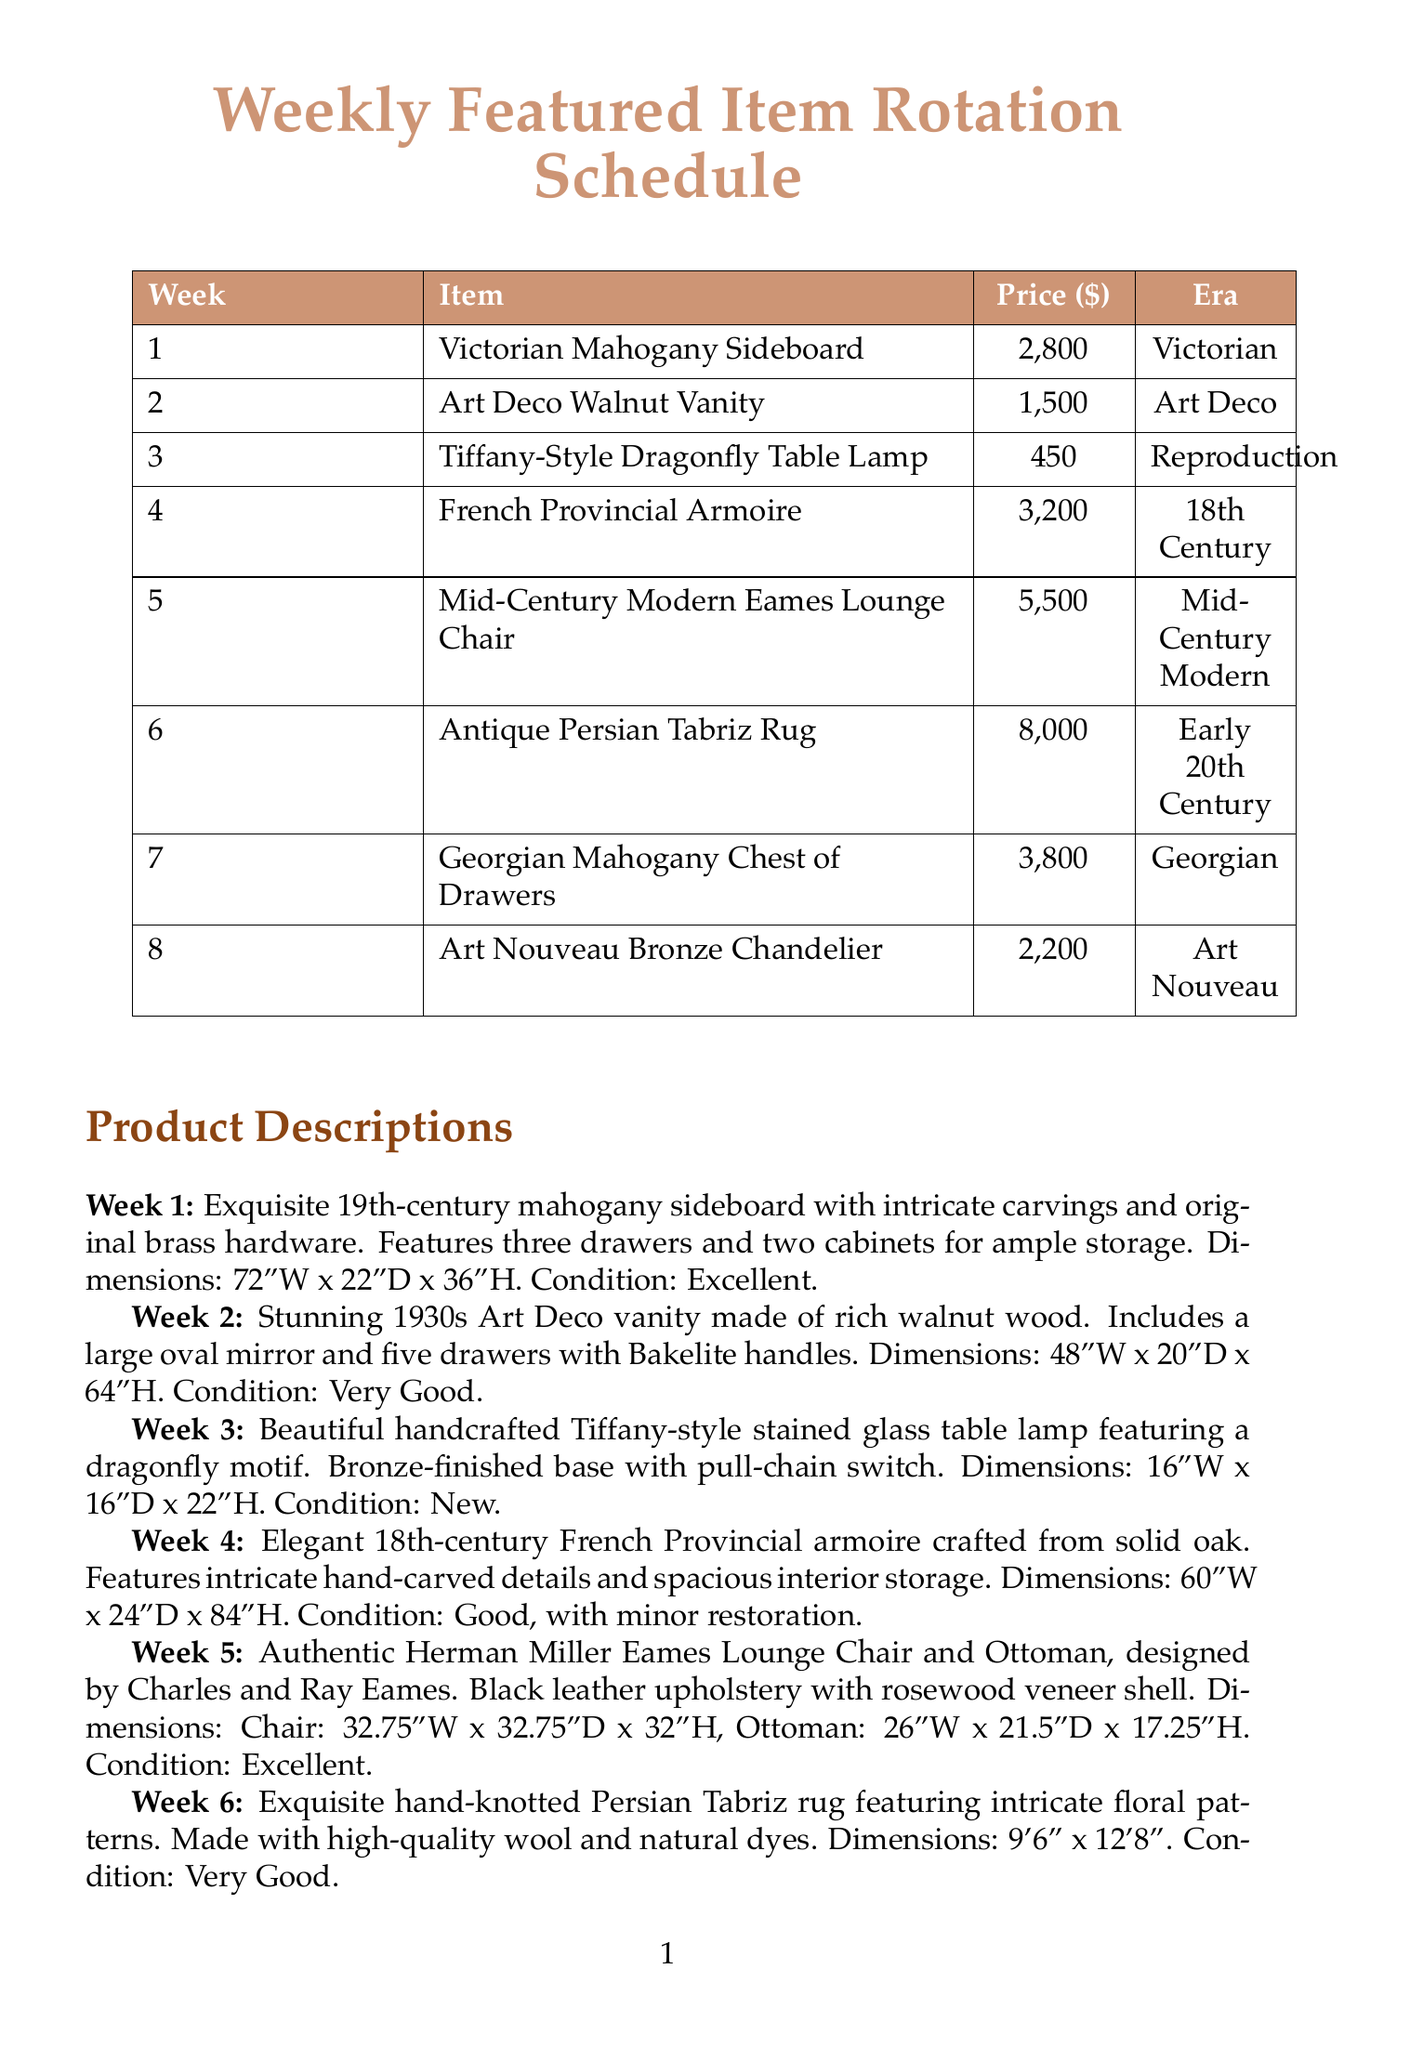What is the price of the Victorian Mahogany Sideboard? The price of the Victorian Mahogany Sideboard is listed in the schedule.
Answer: 2800 What item is featured in week 4? Week 4 features a specific item, which is documented in the schedule.
Answer: French Provincial Armoire What is the condition of the Antique Persian Tabriz Rug? The condition of the Antique Persian Tabriz Rug is provided in its description.
Answer: Very Good How many drawers does the Art Deco Walnut Vanity have? The number of drawers in the Art Deco Walnut Vanity is specified in its description.
Answer: Five Which era does the Mid-Century Modern Eames Lounge Chair belong to? The era associated with the Mid-Century Modern Eames Lounge Chair can be found in the document.
Answer: Mid-Century Modern What is the dimension of the Art Nouveau Bronze Chandelier? The dimensions of the Art Nouveau Bronze Chandelier are detailed in its product description.
Answer: 28"W x 28"D x 30"H How much does the Georgian Mahogany Chest of Drawers cost? The cost of the Georgian Mahogany Chest of Drawers is noted in the item price list.
Answer: 3800 Which week features a Tiffany-Style Dragonfly Table Lamp? The week in which the Tiffany-Style Dragonfly Table Lamp is showcased can be found in the schedule.
Answer: Week 3 